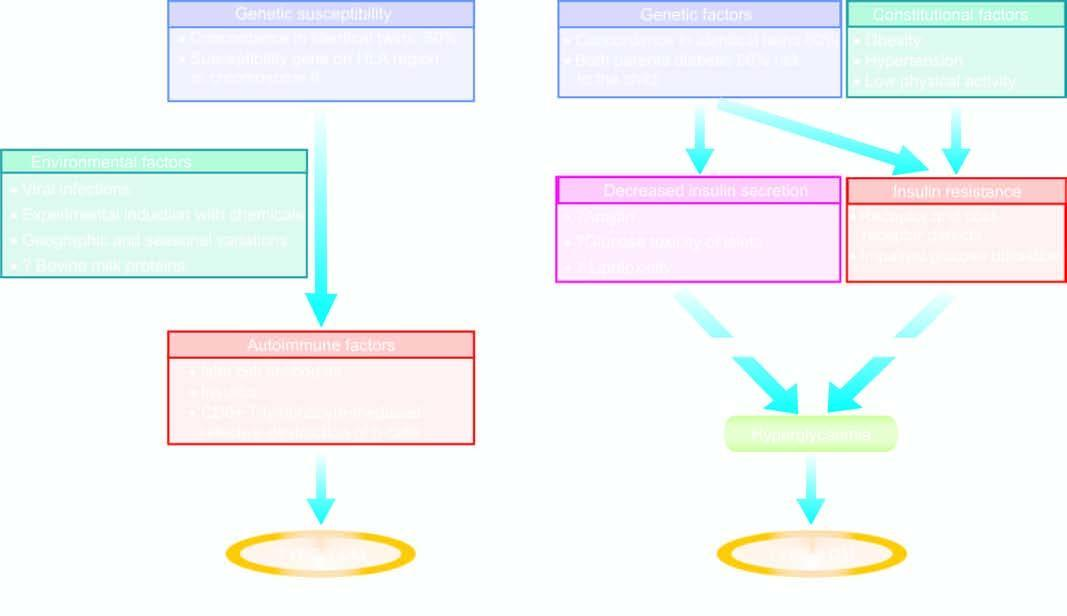what is involvedd in pathogenesis of two main types of diabetes mellitus?
Answer the question using a single word or phrase. Chematic mechanisms 